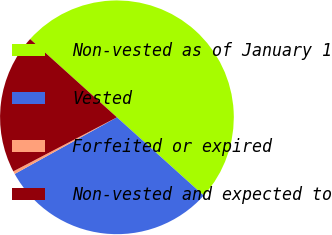Convert chart. <chart><loc_0><loc_0><loc_500><loc_500><pie_chart><fcel>Non-vested as of January 1<fcel>Vested<fcel>Forfeited or expired<fcel>Non-vested and expected to<nl><fcel>50.0%<fcel>30.27%<fcel>0.4%<fcel>19.33%<nl></chart> 